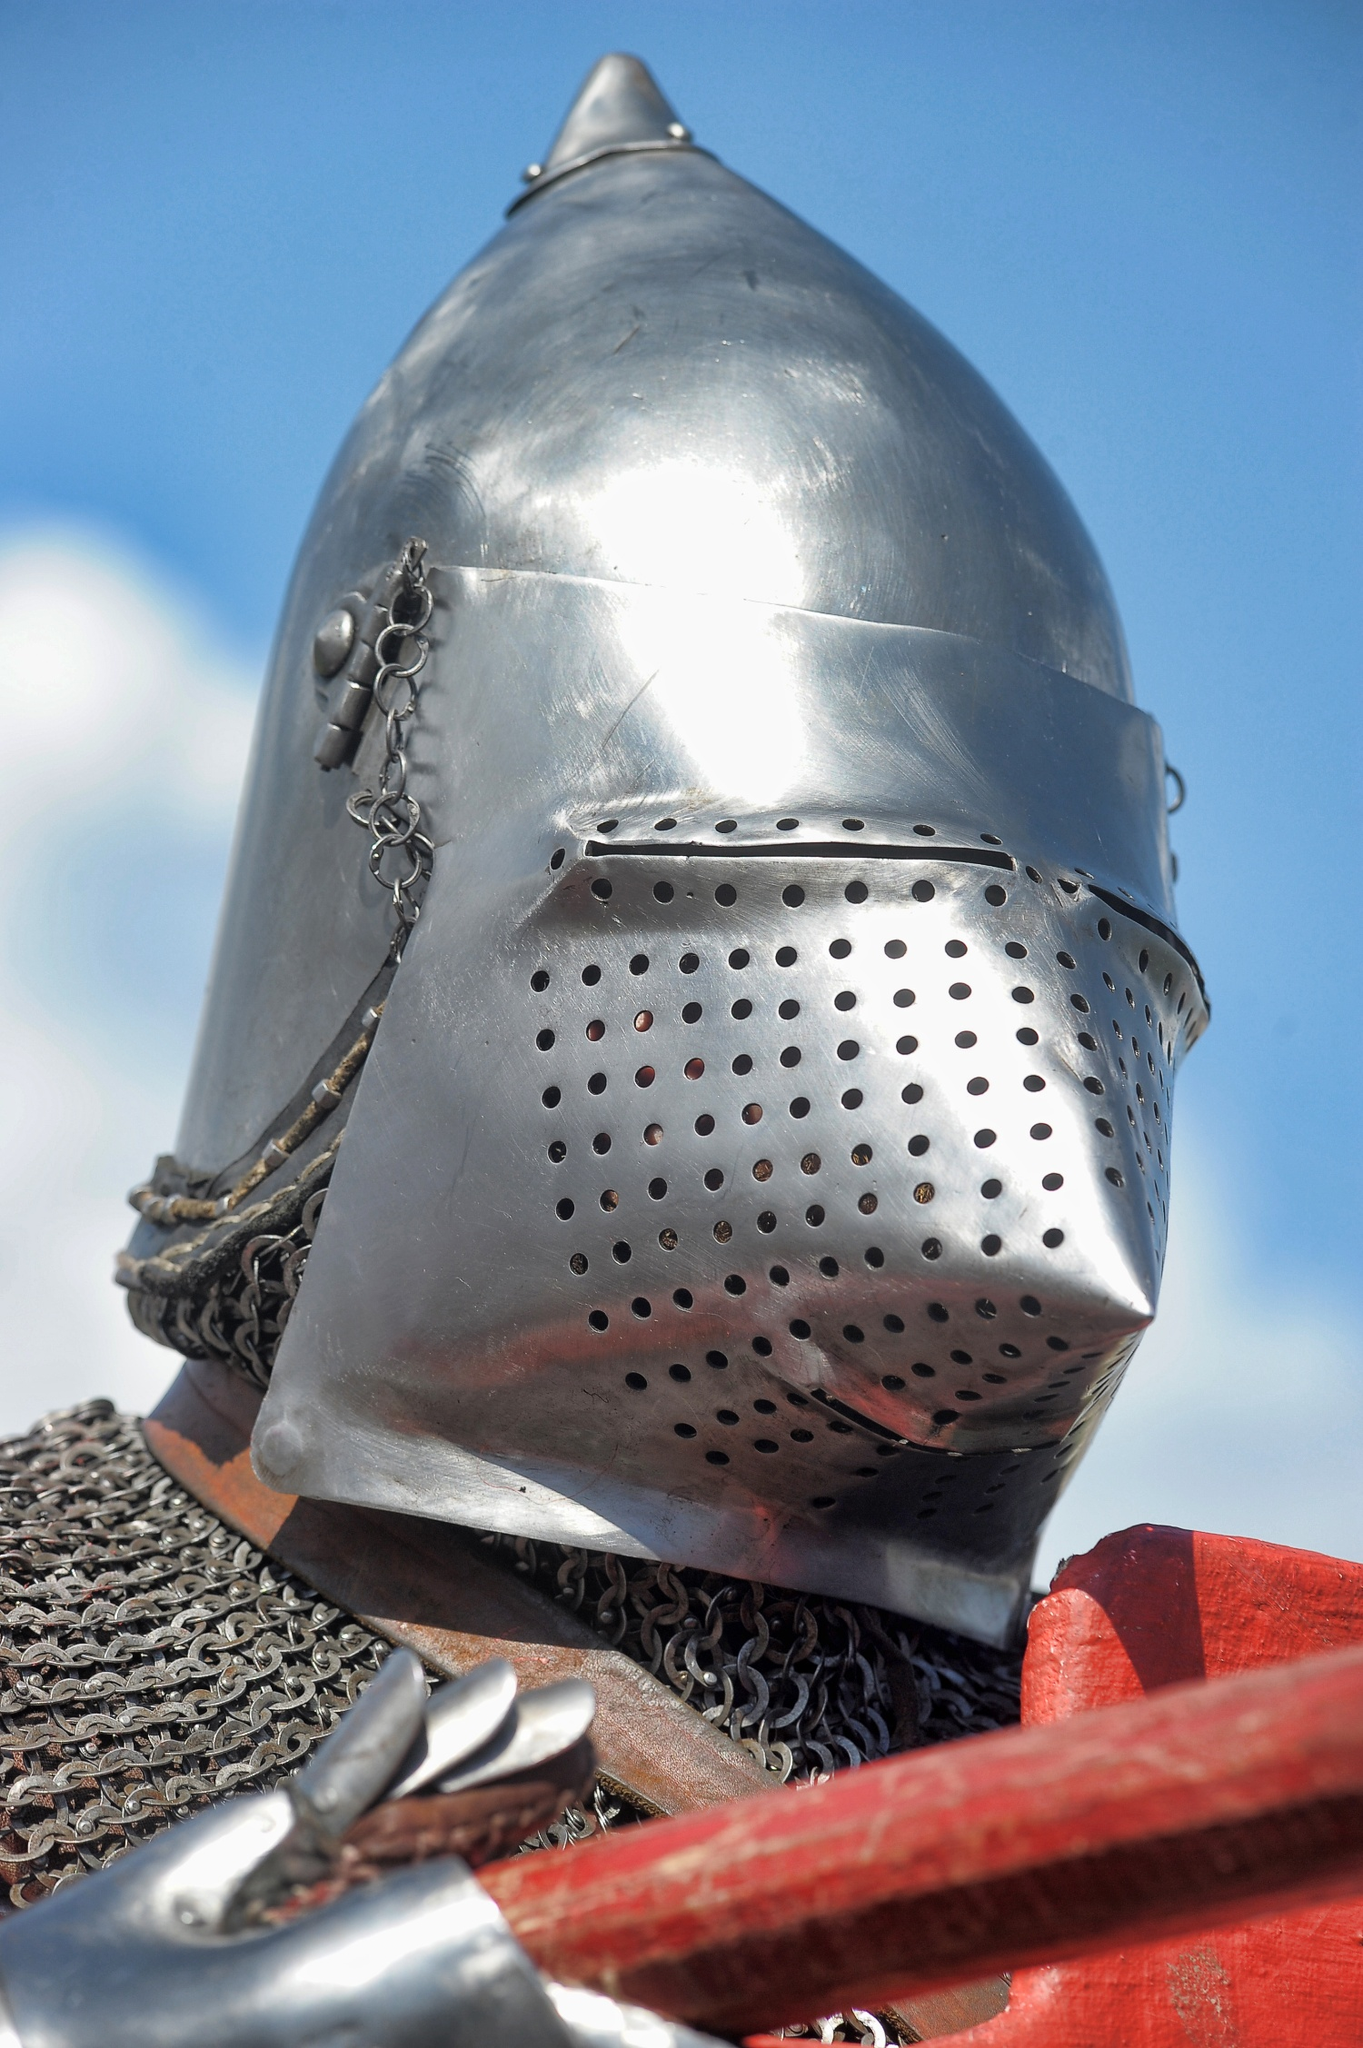What do you think is going on in this snapshot? The image captures a scene of medieval times, featuring a knight's helmet and a part of their armor. The helmet, crafted from metal, boasts a pointed top and is complemented by a chainmail neck guard. The faceplate, perforated with small holes for visibility and ventilation, is securely attached to the helmet with a chain. 

To the right of the helmet, a glimpse of the knight's metal armor can be seen. The armor and helmet are not worn but are resting on a red wooden structure, perhaps a stand or display. 

The backdrop of the image is a clear blue sky dotted with a few clouds, suggesting an outdoor setting. The vivid contrast between the metallic armor and the azure sky adds a dramatic effect to the scene. Despite the absence of a knight, the image tells a story of chivalry and valor, evoking a sense of history and adventure. 